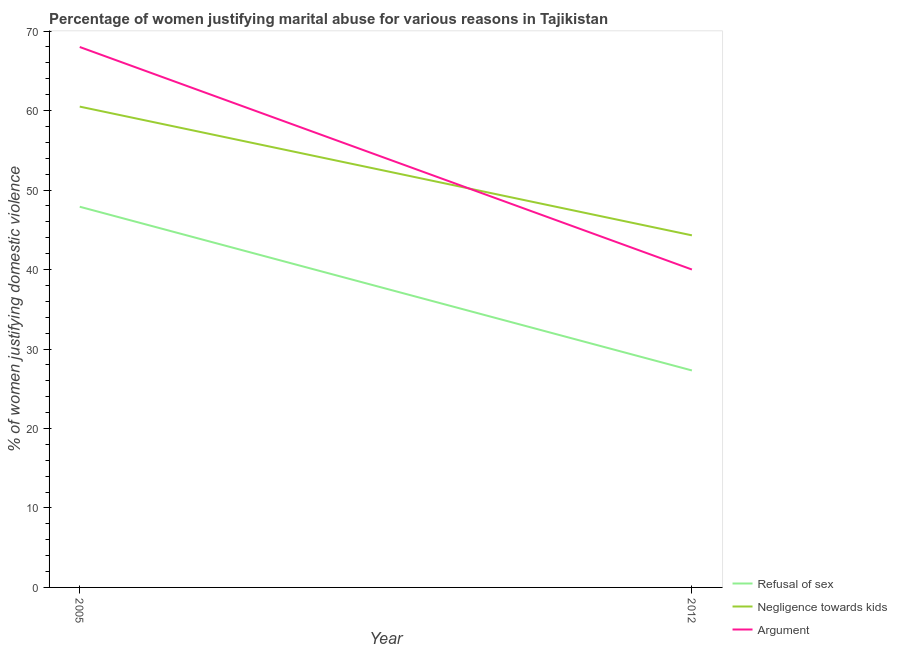What is the percentage of women justifying domestic violence due to refusal of sex in 2005?
Ensure brevity in your answer.  47.9. Across all years, what is the maximum percentage of women justifying domestic violence due to arguments?
Your answer should be very brief. 68. Across all years, what is the minimum percentage of women justifying domestic violence due to negligence towards kids?
Ensure brevity in your answer.  44.3. What is the total percentage of women justifying domestic violence due to negligence towards kids in the graph?
Your answer should be very brief. 104.8. What is the difference between the percentage of women justifying domestic violence due to negligence towards kids in 2005 and that in 2012?
Ensure brevity in your answer.  16.2. What is the difference between the percentage of women justifying domestic violence due to arguments in 2012 and the percentage of women justifying domestic violence due to refusal of sex in 2005?
Keep it short and to the point. -7.9. What is the average percentage of women justifying domestic violence due to negligence towards kids per year?
Offer a terse response. 52.4. In the year 2005, what is the difference between the percentage of women justifying domestic violence due to negligence towards kids and percentage of women justifying domestic violence due to arguments?
Ensure brevity in your answer.  -7.5. In how many years, is the percentage of women justifying domestic violence due to arguments greater than 64 %?
Keep it short and to the point. 1. What is the ratio of the percentage of women justifying domestic violence due to arguments in 2005 to that in 2012?
Ensure brevity in your answer.  1.7. Is the percentage of women justifying domestic violence due to arguments in 2005 less than that in 2012?
Provide a succinct answer. No. In how many years, is the percentage of women justifying domestic violence due to refusal of sex greater than the average percentage of women justifying domestic violence due to refusal of sex taken over all years?
Make the answer very short. 1. Is it the case that in every year, the sum of the percentage of women justifying domestic violence due to refusal of sex and percentage of women justifying domestic violence due to negligence towards kids is greater than the percentage of women justifying domestic violence due to arguments?
Ensure brevity in your answer.  Yes. Does the percentage of women justifying domestic violence due to arguments monotonically increase over the years?
Keep it short and to the point. No. Is the percentage of women justifying domestic violence due to refusal of sex strictly less than the percentage of women justifying domestic violence due to arguments over the years?
Offer a terse response. Yes. What is the difference between two consecutive major ticks on the Y-axis?
Provide a short and direct response. 10. Are the values on the major ticks of Y-axis written in scientific E-notation?
Your response must be concise. No. Does the graph contain any zero values?
Ensure brevity in your answer.  No. Does the graph contain grids?
Your answer should be compact. No. Where does the legend appear in the graph?
Ensure brevity in your answer.  Bottom right. How are the legend labels stacked?
Provide a short and direct response. Vertical. What is the title of the graph?
Ensure brevity in your answer.  Percentage of women justifying marital abuse for various reasons in Tajikistan. What is the label or title of the Y-axis?
Keep it short and to the point. % of women justifying domestic violence. What is the % of women justifying domestic violence in Refusal of sex in 2005?
Your answer should be very brief. 47.9. What is the % of women justifying domestic violence in Negligence towards kids in 2005?
Make the answer very short. 60.5. What is the % of women justifying domestic violence of Refusal of sex in 2012?
Make the answer very short. 27.3. What is the % of women justifying domestic violence of Negligence towards kids in 2012?
Provide a short and direct response. 44.3. What is the % of women justifying domestic violence of Argument in 2012?
Offer a terse response. 40. Across all years, what is the maximum % of women justifying domestic violence of Refusal of sex?
Provide a short and direct response. 47.9. Across all years, what is the maximum % of women justifying domestic violence in Negligence towards kids?
Keep it short and to the point. 60.5. Across all years, what is the minimum % of women justifying domestic violence in Refusal of sex?
Offer a terse response. 27.3. Across all years, what is the minimum % of women justifying domestic violence of Negligence towards kids?
Provide a short and direct response. 44.3. Across all years, what is the minimum % of women justifying domestic violence in Argument?
Provide a succinct answer. 40. What is the total % of women justifying domestic violence of Refusal of sex in the graph?
Your answer should be very brief. 75.2. What is the total % of women justifying domestic violence in Negligence towards kids in the graph?
Ensure brevity in your answer.  104.8. What is the total % of women justifying domestic violence of Argument in the graph?
Your answer should be very brief. 108. What is the difference between the % of women justifying domestic violence of Refusal of sex in 2005 and that in 2012?
Your response must be concise. 20.6. What is the difference between the % of women justifying domestic violence in Negligence towards kids in 2005 and that in 2012?
Provide a short and direct response. 16.2. What is the difference between the % of women justifying domestic violence in Argument in 2005 and that in 2012?
Make the answer very short. 28. What is the difference between the % of women justifying domestic violence in Refusal of sex in 2005 and the % of women justifying domestic violence in Negligence towards kids in 2012?
Give a very brief answer. 3.6. What is the difference between the % of women justifying domestic violence in Negligence towards kids in 2005 and the % of women justifying domestic violence in Argument in 2012?
Your answer should be very brief. 20.5. What is the average % of women justifying domestic violence of Refusal of sex per year?
Your answer should be compact. 37.6. What is the average % of women justifying domestic violence in Negligence towards kids per year?
Provide a short and direct response. 52.4. In the year 2005, what is the difference between the % of women justifying domestic violence of Refusal of sex and % of women justifying domestic violence of Argument?
Your answer should be very brief. -20.1. In the year 2012, what is the difference between the % of women justifying domestic violence in Refusal of sex and % of women justifying domestic violence in Negligence towards kids?
Provide a succinct answer. -17. In the year 2012, what is the difference between the % of women justifying domestic violence in Negligence towards kids and % of women justifying domestic violence in Argument?
Your response must be concise. 4.3. What is the ratio of the % of women justifying domestic violence of Refusal of sex in 2005 to that in 2012?
Give a very brief answer. 1.75. What is the ratio of the % of women justifying domestic violence of Negligence towards kids in 2005 to that in 2012?
Offer a terse response. 1.37. What is the ratio of the % of women justifying domestic violence in Argument in 2005 to that in 2012?
Make the answer very short. 1.7. What is the difference between the highest and the second highest % of women justifying domestic violence of Refusal of sex?
Make the answer very short. 20.6. What is the difference between the highest and the second highest % of women justifying domestic violence of Negligence towards kids?
Your response must be concise. 16.2. What is the difference between the highest and the second highest % of women justifying domestic violence in Argument?
Offer a very short reply. 28. What is the difference between the highest and the lowest % of women justifying domestic violence in Refusal of sex?
Offer a terse response. 20.6. 